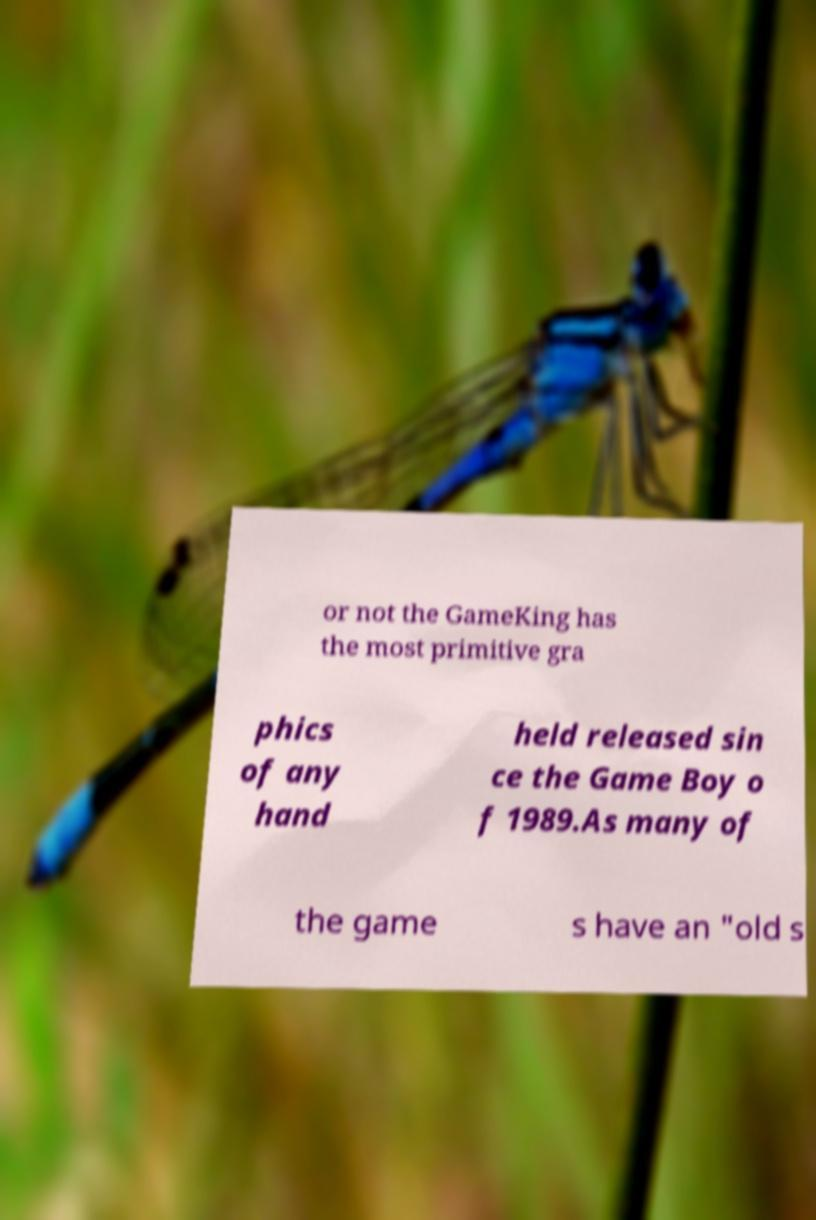I need the written content from this picture converted into text. Can you do that? or not the GameKing has the most primitive gra phics of any hand held released sin ce the Game Boy o f 1989.As many of the game s have an "old s 